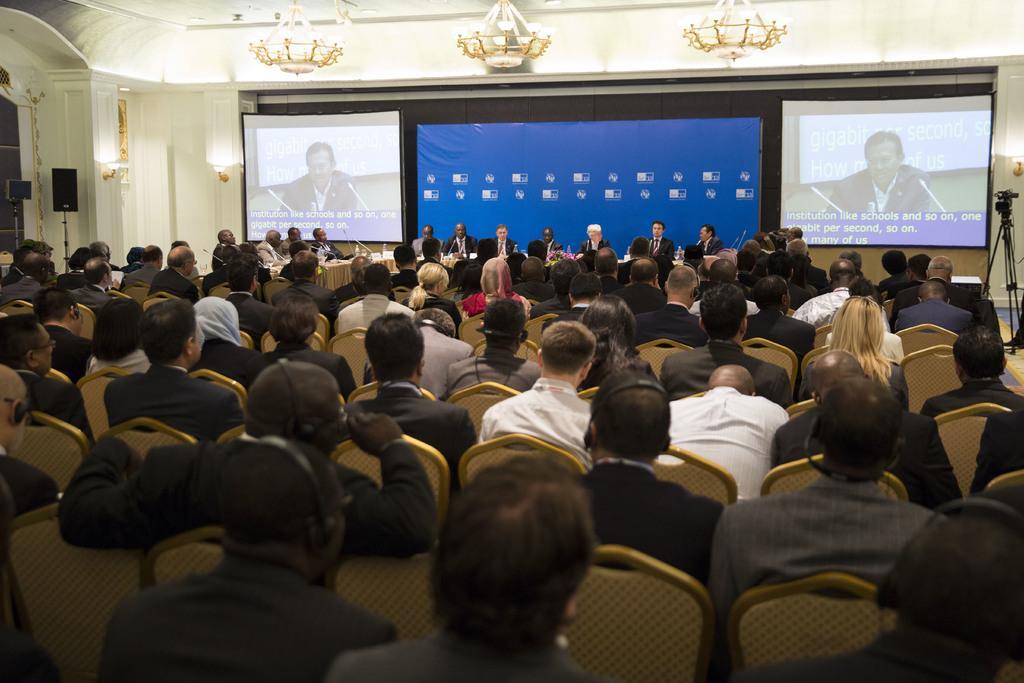Could you give a brief overview of what you see in this image? In this image, we can see persons wearing clothes and sitting on chairs. There are screens in the middle of the image. There are lights at the top of the image. There is a tripod on the right side of the image. There is a speaker on the left side of the image. 